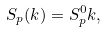Convert formula to latex. <formula><loc_0><loc_0><loc_500><loc_500>S _ { p } ( k ) = S _ { p } ^ { 0 } k ,</formula> 